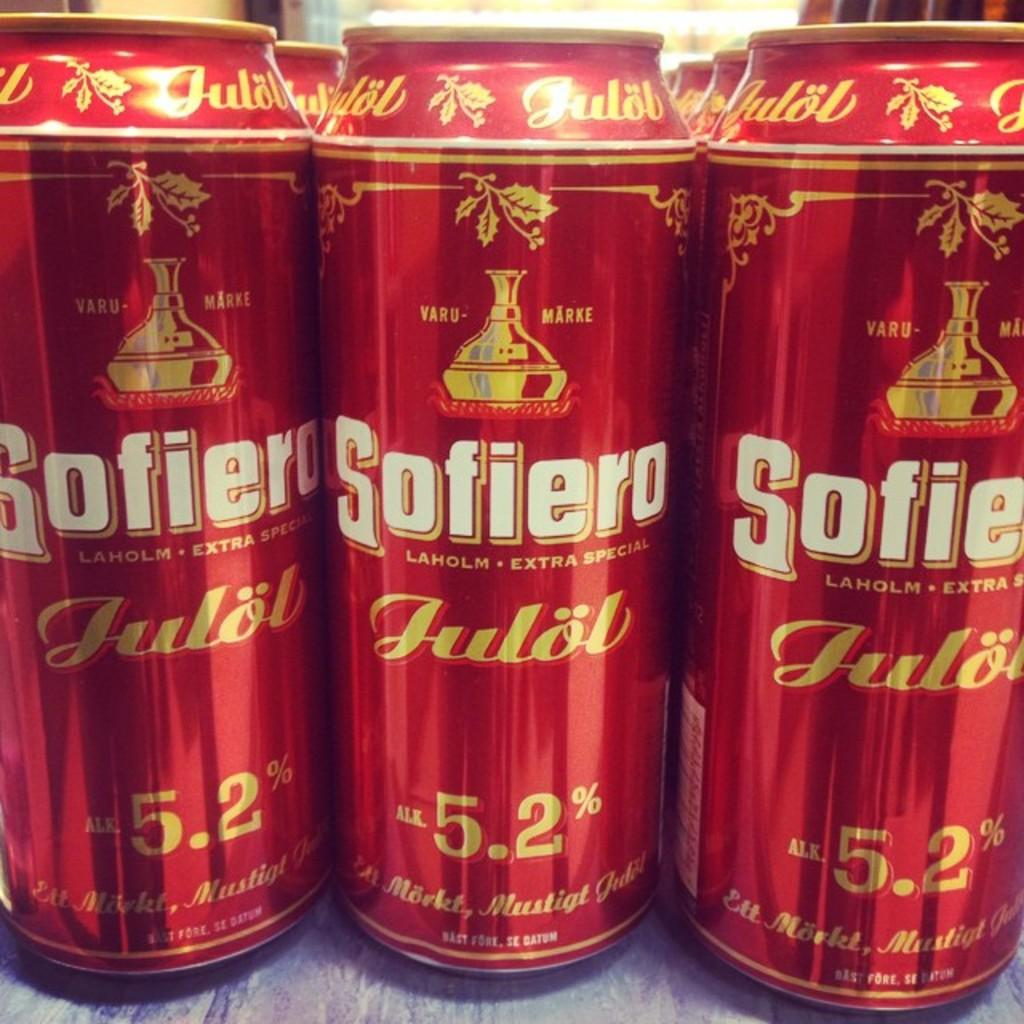<image>
Give a short and clear explanation of the subsequent image. Three cans of 5.2% Sofiero Julob beer lined up in front of other cans.. 